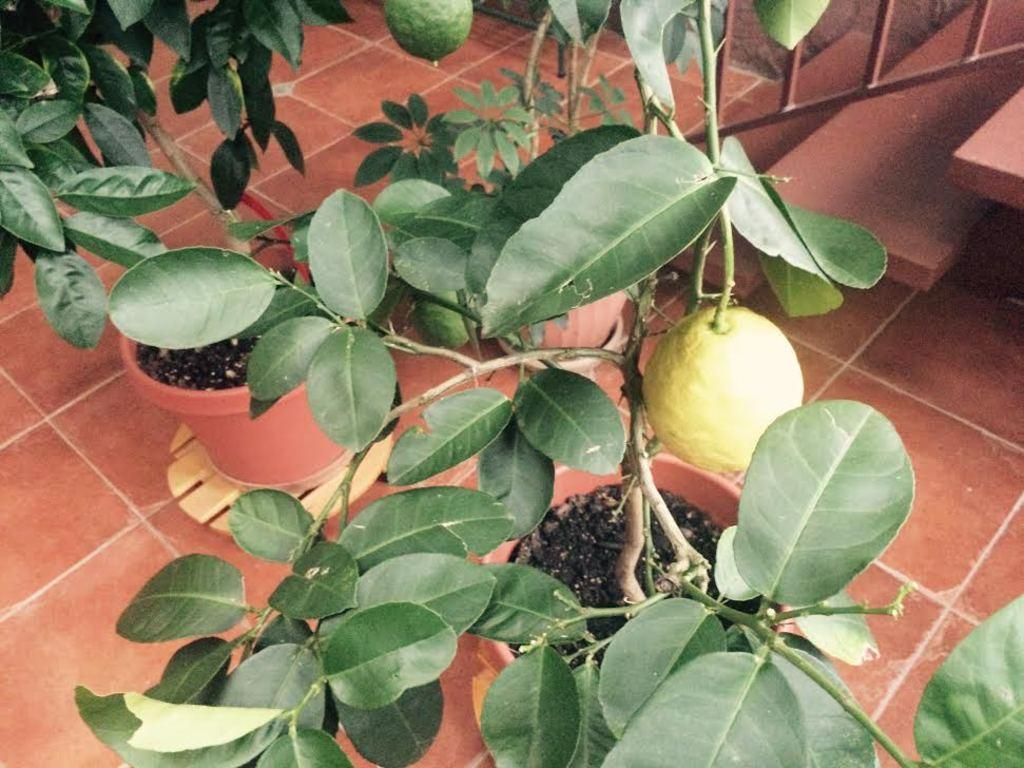What type of plants are in the image? There are plants in pots in the image. What else can be seen in the image besides the plants? There are fruits in the image. What architectural feature is present at the bottom of the image? There are stairs at the bottom of the image. What is associated with the stairs for safety purposes? There is a railing associated with the stairs. What surface is visible in the image? There is a floor visible in the image. What type of bird is perched on the boundary in the image? There is no bird or boundary present in the image. What type of bulb is visible in the image? There is no bulb present in the image. 